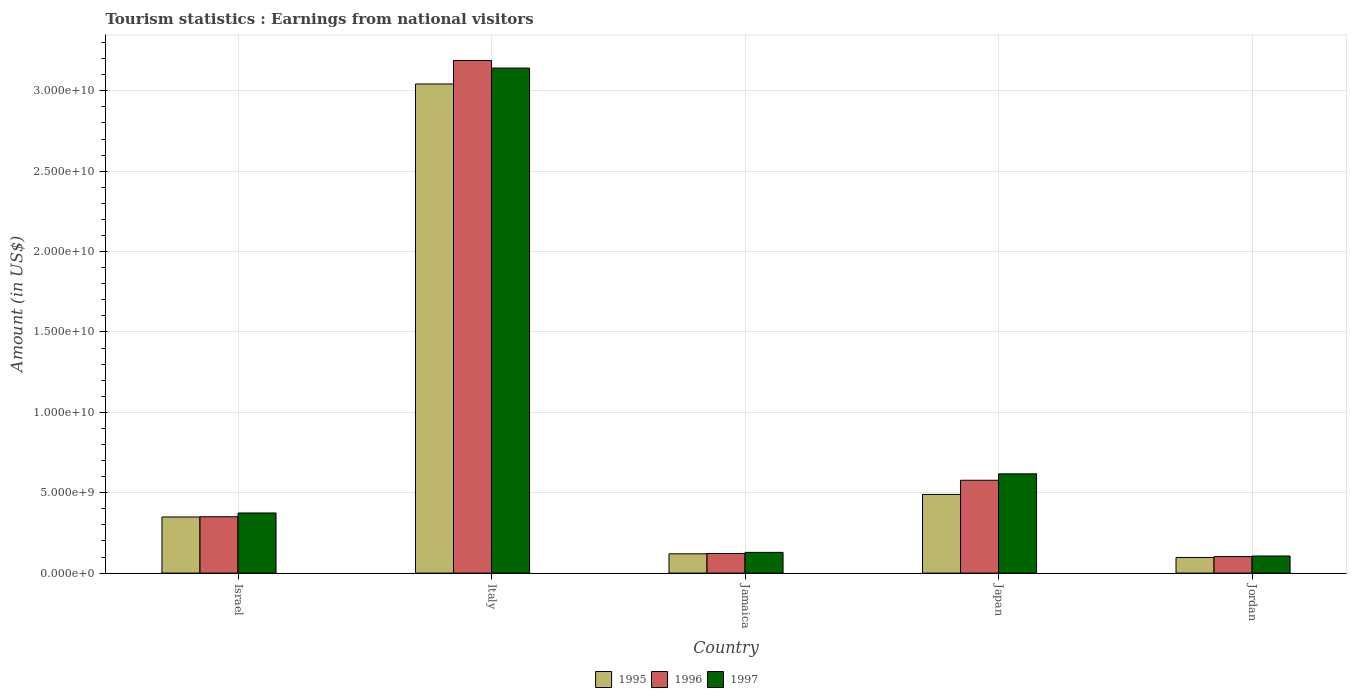How many different coloured bars are there?
Provide a short and direct response. 3. How many groups of bars are there?
Give a very brief answer. 5. Are the number of bars per tick equal to the number of legend labels?
Offer a terse response. Yes. Are the number of bars on each tick of the X-axis equal?
Ensure brevity in your answer.  Yes. How many bars are there on the 1st tick from the right?
Provide a succinct answer. 3. What is the label of the 3rd group of bars from the left?
Offer a very short reply. Jamaica. In how many cases, is the number of bars for a given country not equal to the number of legend labels?
Your response must be concise. 0. What is the earnings from national visitors in 1995 in Italy?
Make the answer very short. 3.04e+1. Across all countries, what is the maximum earnings from national visitors in 1995?
Give a very brief answer. 3.04e+1. Across all countries, what is the minimum earnings from national visitors in 1996?
Make the answer very short. 1.03e+09. In which country was the earnings from national visitors in 1995 maximum?
Provide a succinct answer. Italy. In which country was the earnings from national visitors in 1997 minimum?
Your answer should be very brief. Jordan. What is the total earnings from national visitors in 1996 in the graph?
Offer a very short reply. 4.34e+1. What is the difference between the earnings from national visitors in 1997 in Italy and that in Japan?
Offer a terse response. 2.52e+1. What is the difference between the earnings from national visitors in 1995 in Italy and the earnings from national visitors in 1997 in Japan?
Offer a terse response. 2.43e+1. What is the average earnings from national visitors in 1997 per country?
Make the answer very short. 8.74e+09. What is the difference between the earnings from national visitors of/in 1997 and earnings from national visitors of/in 1995 in Jamaica?
Provide a succinct answer. 9.10e+07. In how many countries, is the earnings from national visitors in 1996 greater than 26000000000 US$?
Offer a terse response. 1. What is the ratio of the earnings from national visitors in 1997 in Italy to that in Jamaica?
Offer a very short reply. 24.35. Is the difference between the earnings from national visitors in 1997 in Italy and Japan greater than the difference between the earnings from national visitors in 1995 in Italy and Japan?
Offer a very short reply. No. What is the difference between the highest and the second highest earnings from national visitors in 1995?
Your answer should be compact. 2.55e+1. What is the difference between the highest and the lowest earnings from national visitors in 1996?
Provide a short and direct response. 3.09e+1. In how many countries, is the earnings from national visitors in 1995 greater than the average earnings from national visitors in 1995 taken over all countries?
Provide a short and direct response. 1. What does the 2nd bar from the left in Italy represents?
Ensure brevity in your answer.  1996. How many countries are there in the graph?
Offer a very short reply. 5. Are the values on the major ticks of Y-axis written in scientific E-notation?
Make the answer very short. Yes. Does the graph contain grids?
Your answer should be very brief. Yes. How are the legend labels stacked?
Make the answer very short. Horizontal. What is the title of the graph?
Offer a very short reply. Tourism statistics : Earnings from national visitors. What is the label or title of the Y-axis?
Your response must be concise. Amount (in US$). What is the Amount (in US$) of 1995 in Israel?
Your answer should be very brief. 3.49e+09. What is the Amount (in US$) in 1996 in Israel?
Make the answer very short. 3.51e+09. What is the Amount (in US$) of 1997 in Israel?
Make the answer very short. 3.74e+09. What is the Amount (in US$) in 1995 in Italy?
Provide a short and direct response. 3.04e+1. What is the Amount (in US$) of 1996 in Italy?
Your response must be concise. 3.19e+1. What is the Amount (in US$) in 1997 in Italy?
Give a very brief answer. 3.14e+1. What is the Amount (in US$) of 1995 in Jamaica?
Give a very brief answer. 1.20e+09. What is the Amount (in US$) of 1996 in Jamaica?
Ensure brevity in your answer.  1.22e+09. What is the Amount (in US$) of 1997 in Jamaica?
Provide a succinct answer. 1.29e+09. What is the Amount (in US$) in 1995 in Japan?
Your response must be concise. 4.89e+09. What is the Amount (in US$) of 1996 in Japan?
Provide a short and direct response. 5.78e+09. What is the Amount (in US$) of 1997 in Japan?
Offer a terse response. 6.18e+09. What is the Amount (in US$) in 1995 in Jordan?
Your answer should be very brief. 9.73e+08. What is the Amount (in US$) of 1996 in Jordan?
Provide a short and direct response. 1.03e+09. What is the Amount (in US$) in 1997 in Jordan?
Provide a succinct answer. 1.06e+09. Across all countries, what is the maximum Amount (in US$) in 1995?
Offer a terse response. 3.04e+1. Across all countries, what is the maximum Amount (in US$) of 1996?
Your answer should be compact. 3.19e+1. Across all countries, what is the maximum Amount (in US$) of 1997?
Keep it short and to the point. 3.14e+1. Across all countries, what is the minimum Amount (in US$) in 1995?
Offer a very short reply. 9.73e+08. Across all countries, what is the minimum Amount (in US$) in 1996?
Ensure brevity in your answer.  1.03e+09. Across all countries, what is the minimum Amount (in US$) in 1997?
Offer a terse response. 1.06e+09. What is the total Amount (in US$) of 1995 in the graph?
Your answer should be compact. 4.10e+1. What is the total Amount (in US$) of 1996 in the graph?
Your response must be concise. 4.34e+1. What is the total Amount (in US$) in 1997 in the graph?
Offer a terse response. 4.37e+1. What is the difference between the Amount (in US$) in 1995 in Israel and that in Italy?
Offer a terse response. -2.69e+1. What is the difference between the Amount (in US$) in 1996 in Israel and that in Italy?
Make the answer very short. -2.84e+1. What is the difference between the Amount (in US$) of 1997 in Israel and that in Italy?
Make the answer very short. -2.77e+1. What is the difference between the Amount (in US$) in 1995 in Israel and that in Jamaica?
Ensure brevity in your answer.  2.29e+09. What is the difference between the Amount (in US$) in 1996 in Israel and that in Jamaica?
Your answer should be very brief. 2.29e+09. What is the difference between the Amount (in US$) of 1997 in Israel and that in Jamaica?
Offer a very short reply. 2.45e+09. What is the difference between the Amount (in US$) in 1995 in Israel and that in Japan?
Offer a terse response. -1.40e+09. What is the difference between the Amount (in US$) of 1996 in Israel and that in Japan?
Keep it short and to the point. -2.27e+09. What is the difference between the Amount (in US$) in 1997 in Israel and that in Japan?
Provide a short and direct response. -2.44e+09. What is the difference between the Amount (in US$) of 1995 in Israel and that in Jordan?
Provide a succinct answer. 2.52e+09. What is the difference between the Amount (in US$) in 1996 in Israel and that in Jordan?
Make the answer very short. 2.48e+09. What is the difference between the Amount (in US$) of 1997 in Israel and that in Jordan?
Keep it short and to the point. 2.68e+09. What is the difference between the Amount (in US$) in 1995 in Italy and that in Jamaica?
Make the answer very short. 2.92e+1. What is the difference between the Amount (in US$) of 1996 in Italy and that in Jamaica?
Provide a succinct answer. 3.07e+1. What is the difference between the Amount (in US$) in 1997 in Italy and that in Jamaica?
Your answer should be compact. 3.01e+1. What is the difference between the Amount (in US$) in 1995 in Italy and that in Japan?
Keep it short and to the point. 2.55e+1. What is the difference between the Amount (in US$) of 1996 in Italy and that in Japan?
Provide a succinct answer. 2.61e+1. What is the difference between the Amount (in US$) in 1997 in Italy and that in Japan?
Your response must be concise. 2.52e+1. What is the difference between the Amount (in US$) in 1995 in Italy and that in Jordan?
Ensure brevity in your answer.  2.95e+1. What is the difference between the Amount (in US$) in 1996 in Italy and that in Jordan?
Keep it short and to the point. 3.09e+1. What is the difference between the Amount (in US$) in 1997 in Italy and that in Jordan?
Ensure brevity in your answer.  3.04e+1. What is the difference between the Amount (in US$) in 1995 in Jamaica and that in Japan?
Provide a succinct answer. -3.70e+09. What is the difference between the Amount (in US$) of 1996 in Jamaica and that in Japan?
Your response must be concise. -4.56e+09. What is the difference between the Amount (in US$) in 1997 in Jamaica and that in Japan?
Provide a short and direct response. -4.88e+09. What is the difference between the Amount (in US$) of 1995 in Jamaica and that in Jordan?
Make the answer very short. 2.26e+08. What is the difference between the Amount (in US$) in 1996 in Jamaica and that in Jordan?
Your answer should be very brief. 1.92e+08. What is the difference between the Amount (in US$) of 1997 in Jamaica and that in Jordan?
Your answer should be very brief. 2.27e+08. What is the difference between the Amount (in US$) in 1995 in Japan and that in Jordan?
Provide a short and direct response. 3.92e+09. What is the difference between the Amount (in US$) of 1996 in Japan and that in Jordan?
Give a very brief answer. 4.75e+09. What is the difference between the Amount (in US$) in 1997 in Japan and that in Jordan?
Provide a short and direct response. 5.11e+09. What is the difference between the Amount (in US$) in 1995 in Israel and the Amount (in US$) in 1996 in Italy?
Provide a succinct answer. -2.84e+1. What is the difference between the Amount (in US$) of 1995 in Israel and the Amount (in US$) of 1997 in Italy?
Make the answer very short. -2.79e+1. What is the difference between the Amount (in US$) in 1996 in Israel and the Amount (in US$) in 1997 in Italy?
Give a very brief answer. -2.79e+1. What is the difference between the Amount (in US$) of 1995 in Israel and the Amount (in US$) of 1996 in Jamaica?
Provide a succinct answer. 2.27e+09. What is the difference between the Amount (in US$) in 1995 in Israel and the Amount (in US$) in 1997 in Jamaica?
Provide a short and direct response. 2.20e+09. What is the difference between the Amount (in US$) in 1996 in Israel and the Amount (in US$) in 1997 in Jamaica?
Offer a very short reply. 2.22e+09. What is the difference between the Amount (in US$) in 1995 in Israel and the Amount (in US$) in 1996 in Japan?
Offer a very short reply. -2.28e+09. What is the difference between the Amount (in US$) of 1995 in Israel and the Amount (in US$) of 1997 in Japan?
Offer a terse response. -2.68e+09. What is the difference between the Amount (in US$) in 1996 in Israel and the Amount (in US$) in 1997 in Japan?
Keep it short and to the point. -2.67e+09. What is the difference between the Amount (in US$) in 1995 in Israel and the Amount (in US$) in 1996 in Jordan?
Offer a very short reply. 2.46e+09. What is the difference between the Amount (in US$) of 1995 in Israel and the Amount (in US$) of 1997 in Jordan?
Provide a short and direct response. 2.43e+09. What is the difference between the Amount (in US$) of 1996 in Israel and the Amount (in US$) of 1997 in Jordan?
Your response must be concise. 2.44e+09. What is the difference between the Amount (in US$) of 1995 in Italy and the Amount (in US$) of 1996 in Jamaica?
Offer a very short reply. 2.92e+1. What is the difference between the Amount (in US$) in 1995 in Italy and the Amount (in US$) in 1997 in Jamaica?
Provide a short and direct response. 2.91e+1. What is the difference between the Amount (in US$) in 1996 in Italy and the Amount (in US$) in 1997 in Jamaica?
Give a very brief answer. 3.06e+1. What is the difference between the Amount (in US$) of 1995 in Italy and the Amount (in US$) of 1996 in Japan?
Offer a very short reply. 2.47e+1. What is the difference between the Amount (in US$) in 1995 in Italy and the Amount (in US$) in 1997 in Japan?
Provide a short and direct response. 2.43e+1. What is the difference between the Amount (in US$) in 1996 in Italy and the Amount (in US$) in 1997 in Japan?
Your response must be concise. 2.57e+1. What is the difference between the Amount (in US$) in 1995 in Italy and the Amount (in US$) in 1996 in Jordan?
Make the answer very short. 2.94e+1. What is the difference between the Amount (in US$) of 1995 in Italy and the Amount (in US$) of 1997 in Jordan?
Offer a very short reply. 2.94e+1. What is the difference between the Amount (in US$) of 1996 in Italy and the Amount (in US$) of 1997 in Jordan?
Offer a terse response. 3.08e+1. What is the difference between the Amount (in US$) in 1995 in Jamaica and the Amount (in US$) in 1996 in Japan?
Make the answer very short. -4.58e+09. What is the difference between the Amount (in US$) of 1995 in Jamaica and the Amount (in US$) of 1997 in Japan?
Your response must be concise. -4.98e+09. What is the difference between the Amount (in US$) of 1996 in Jamaica and the Amount (in US$) of 1997 in Japan?
Make the answer very short. -4.96e+09. What is the difference between the Amount (in US$) in 1995 in Jamaica and the Amount (in US$) in 1996 in Jordan?
Give a very brief answer. 1.73e+08. What is the difference between the Amount (in US$) of 1995 in Jamaica and the Amount (in US$) of 1997 in Jordan?
Your response must be concise. 1.36e+08. What is the difference between the Amount (in US$) of 1996 in Jamaica and the Amount (in US$) of 1997 in Jordan?
Make the answer very short. 1.55e+08. What is the difference between the Amount (in US$) of 1995 in Japan and the Amount (in US$) of 1996 in Jordan?
Ensure brevity in your answer.  3.87e+09. What is the difference between the Amount (in US$) of 1995 in Japan and the Amount (in US$) of 1997 in Jordan?
Provide a succinct answer. 3.83e+09. What is the difference between the Amount (in US$) of 1996 in Japan and the Amount (in US$) of 1997 in Jordan?
Your response must be concise. 4.71e+09. What is the average Amount (in US$) of 1995 per country?
Provide a short and direct response. 8.20e+09. What is the average Amount (in US$) of 1996 per country?
Ensure brevity in your answer.  8.68e+09. What is the average Amount (in US$) of 1997 per country?
Your answer should be very brief. 8.74e+09. What is the difference between the Amount (in US$) in 1995 and Amount (in US$) in 1996 in Israel?
Keep it short and to the point. -1.50e+07. What is the difference between the Amount (in US$) in 1995 and Amount (in US$) in 1997 in Israel?
Offer a terse response. -2.49e+08. What is the difference between the Amount (in US$) in 1996 and Amount (in US$) in 1997 in Israel?
Offer a terse response. -2.34e+08. What is the difference between the Amount (in US$) in 1995 and Amount (in US$) in 1996 in Italy?
Offer a terse response. -1.46e+09. What is the difference between the Amount (in US$) in 1995 and Amount (in US$) in 1997 in Italy?
Provide a short and direct response. -9.90e+08. What is the difference between the Amount (in US$) in 1996 and Amount (in US$) in 1997 in Italy?
Your answer should be compact. 4.70e+08. What is the difference between the Amount (in US$) of 1995 and Amount (in US$) of 1996 in Jamaica?
Keep it short and to the point. -1.90e+07. What is the difference between the Amount (in US$) of 1995 and Amount (in US$) of 1997 in Jamaica?
Your answer should be compact. -9.10e+07. What is the difference between the Amount (in US$) in 1996 and Amount (in US$) in 1997 in Jamaica?
Keep it short and to the point. -7.20e+07. What is the difference between the Amount (in US$) in 1995 and Amount (in US$) in 1996 in Japan?
Provide a succinct answer. -8.81e+08. What is the difference between the Amount (in US$) in 1995 and Amount (in US$) in 1997 in Japan?
Give a very brief answer. -1.28e+09. What is the difference between the Amount (in US$) in 1996 and Amount (in US$) in 1997 in Japan?
Offer a terse response. -4.00e+08. What is the difference between the Amount (in US$) of 1995 and Amount (in US$) of 1996 in Jordan?
Provide a short and direct response. -5.30e+07. What is the difference between the Amount (in US$) in 1995 and Amount (in US$) in 1997 in Jordan?
Offer a terse response. -9.00e+07. What is the difference between the Amount (in US$) in 1996 and Amount (in US$) in 1997 in Jordan?
Make the answer very short. -3.70e+07. What is the ratio of the Amount (in US$) in 1995 in Israel to that in Italy?
Provide a succinct answer. 0.11. What is the ratio of the Amount (in US$) of 1996 in Israel to that in Italy?
Offer a very short reply. 0.11. What is the ratio of the Amount (in US$) of 1997 in Israel to that in Italy?
Ensure brevity in your answer.  0.12. What is the ratio of the Amount (in US$) of 1995 in Israel to that in Jamaica?
Provide a succinct answer. 2.91. What is the ratio of the Amount (in US$) in 1996 in Israel to that in Jamaica?
Provide a short and direct response. 2.88. What is the ratio of the Amount (in US$) in 1997 in Israel to that in Jamaica?
Your response must be concise. 2.9. What is the ratio of the Amount (in US$) of 1995 in Israel to that in Japan?
Your answer should be very brief. 0.71. What is the ratio of the Amount (in US$) of 1996 in Israel to that in Japan?
Provide a short and direct response. 0.61. What is the ratio of the Amount (in US$) of 1997 in Israel to that in Japan?
Give a very brief answer. 0.61. What is the ratio of the Amount (in US$) in 1995 in Israel to that in Jordan?
Provide a short and direct response. 3.59. What is the ratio of the Amount (in US$) in 1996 in Israel to that in Jordan?
Your answer should be compact. 3.42. What is the ratio of the Amount (in US$) of 1997 in Israel to that in Jordan?
Offer a terse response. 3.52. What is the ratio of the Amount (in US$) in 1995 in Italy to that in Jamaica?
Your response must be concise. 25.38. What is the ratio of the Amount (in US$) of 1996 in Italy to that in Jamaica?
Offer a terse response. 26.18. What is the ratio of the Amount (in US$) of 1997 in Italy to that in Jamaica?
Provide a short and direct response. 24.35. What is the ratio of the Amount (in US$) in 1995 in Italy to that in Japan?
Offer a terse response. 6.22. What is the ratio of the Amount (in US$) of 1996 in Italy to that in Japan?
Keep it short and to the point. 5.52. What is the ratio of the Amount (in US$) of 1997 in Italy to that in Japan?
Your answer should be very brief. 5.09. What is the ratio of the Amount (in US$) in 1995 in Italy to that in Jordan?
Provide a short and direct response. 31.27. What is the ratio of the Amount (in US$) in 1996 in Italy to that in Jordan?
Ensure brevity in your answer.  31.08. What is the ratio of the Amount (in US$) in 1997 in Italy to that in Jordan?
Keep it short and to the point. 29.55. What is the ratio of the Amount (in US$) of 1995 in Jamaica to that in Japan?
Offer a very short reply. 0.24. What is the ratio of the Amount (in US$) in 1996 in Jamaica to that in Japan?
Keep it short and to the point. 0.21. What is the ratio of the Amount (in US$) in 1997 in Jamaica to that in Japan?
Provide a succinct answer. 0.21. What is the ratio of the Amount (in US$) in 1995 in Jamaica to that in Jordan?
Your answer should be compact. 1.23. What is the ratio of the Amount (in US$) of 1996 in Jamaica to that in Jordan?
Keep it short and to the point. 1.19. What is the ratio of the Amount (in US$) of 1997 in Jamaica to that in Jordan?
Offer a terse response. 1.21. What is the ratio of the Amount (in US$) in 1995 in Japan to that in Jordan?
Provide a succinct answer. 5.03. What is the ratio of the Amount (in US$) of 1996 in Japan to that in Jordan?
Provide a succinct answer. 5.63. What is the ratio of the Amount (in US$) in 1997 in Japan to that in Jordan?
Your answer should be very brief. 5.81. What is the difference between the highest and the second highest Amount (in US$) in 1995?
Provide a short and direct response. 2.55e+1. What is the difference between the highest and the second highest Amount (in US$) of 1996?
Provide a short and direct response. 2.61e+1. What is the difference between the highest and the second highest Amount (in US$) in 1997?
Provide a succinct answer. 2.52e+1. What is the difference between the highest and the lowest Amount (in US$) in 1995?
Your answer should be compact. 2.95e+1. What is the difference between the highest and the lowest Amount (in US$) in 1996?
Ensure brevity in your answer.  3.09e+1. What is the difference between the highest and the lowest Amount (in US$) in 1997?
Ensure brevity in your answer.  3.04e+1. 